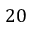Convert formula to latex. <formula><loc_0><loc_0><loc_500><loc_500>2 0</formula> 